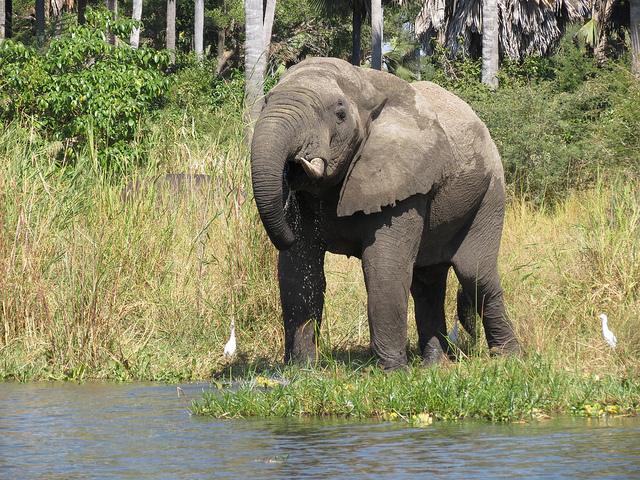Is this an adult Elephant?
Be succinct. Yes. How many birds are next to the right side of the elephant?
Concise answer only. 1. Is the elephant trying to go ashore?
Quick response, please. No. Is the elephant drinking water?
Be succinct. Yes. Is the elephant an adult?
Short answer required. Yes. Is this a baby elephant?
Quick response, please. Yes. Is the elephant happy?
Answer briefly. Yes. How many elephants are babies?
Be succinct. 0. Is there a fence in the background of this picture?
Write a very short answer. No. 